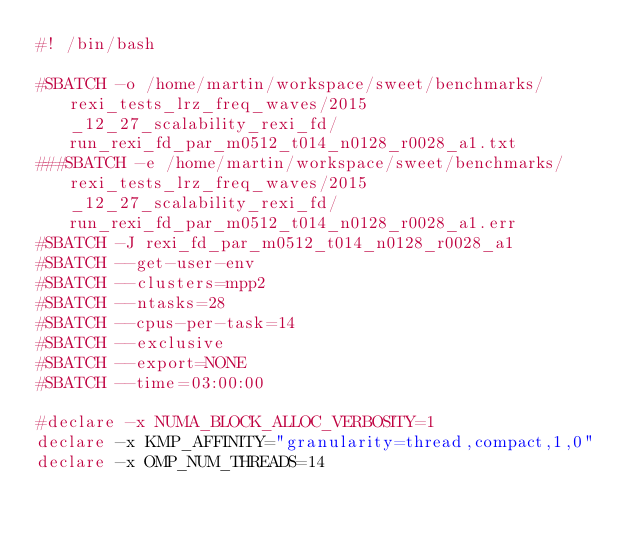<code> <loc_0><loc_0><loc_500><loc_500><_Bash_>#! /bin/bash

#SBATCH -o /home/martin/workspace/sweet/benchmarks/rexi_tests_lrz_freq_waves/2015_12_27_scalability_rexi_fd/run_rexi_fd_par_m0512_t014_n0128_r0028_a1.txt
###SBATCH -e /home/martin/workspace/sweet/benchmarks/rexi_tests_lrz_freq_waves/2015_12_27_scalability_rexi_fd/run_rexi_fd_par_m0512_t014_n0128_r0028_a1.err
#SBATCH -J rexi_fd_par_m0512_t014_n0128_r0028_a1
#SBATCH --get-user-env
#SBATCH --clusters=mpp2
#SBATCH --ntasks=28
#SBATCH --cpus-per-task=14
#SBATCH --exclusive
#SBATCH --export=NONE
#SBATCH --time=03:00:00

#declare -x NUMA_BLOCK_ALLOC_VERBOSITY=1
declare -x KMP_AFFINITY="granularity=thread,compact,1,0"
declare -x OMP_NUM_THREADS=14

</code> 